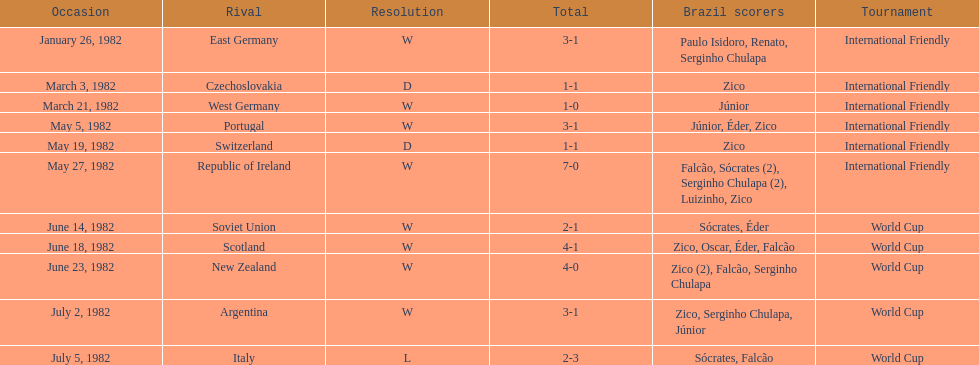How many times did brazil play west germany during the 1982 season? 1. 